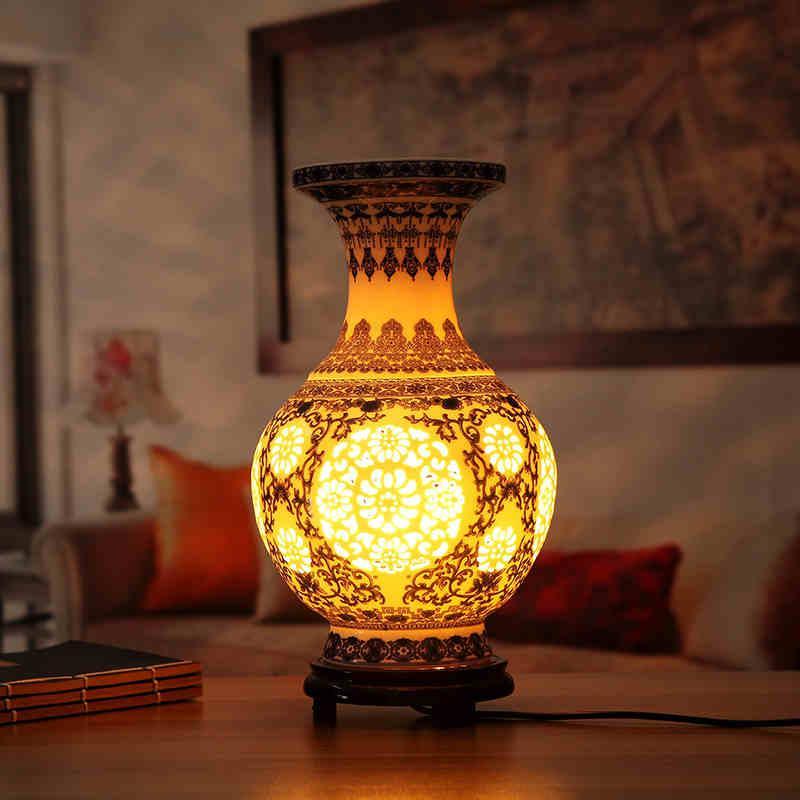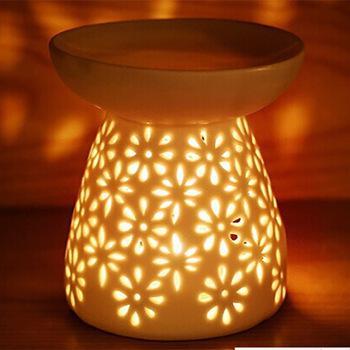The first image is the image on the left, the second image is the image on the right. Examine the images to the left and right. Is the description "A glowing vase is sitting on a wood-like stand with at least two short legs." accurate? Answer yes or no. Yes. The first image is the image on the left, the second image is the image on the right. Considering the images on both sides, is "One vase has a narrow neck, a footed base, and a circular design on the front, and it is seen head-on." valid? Answer yes or no. Yes. 